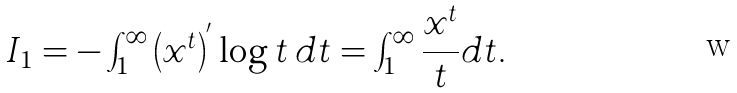<formula> <loc_0><loc_0><loc_500><loc_500>I _ { 1 } = - \int _ { 1 } ^ { \infty } \left ( x ^ { t } \right ) ^ { ^ { \prime } } \log t \, d t = \int _ { 1 } ^ { \infty } \frac { x ^ { t } } { t } d t .</formula> 